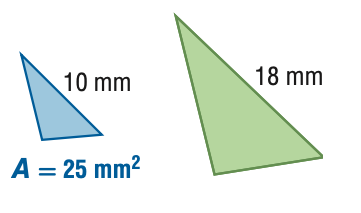Question: For the pair of similar figures, find the area of the green figure.
Choices:
A. 7.7
B. 13.9
C. 45
D. 81
Answer with the letter. Answer: D 